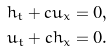Convert formula to latex. <formula><loc_0><loc_0><loc_500><loc_500>h _ { t } + c u _ { x } & = 0 , \\ u _ { t } + c h _ { x } & = 0 .</formula> 